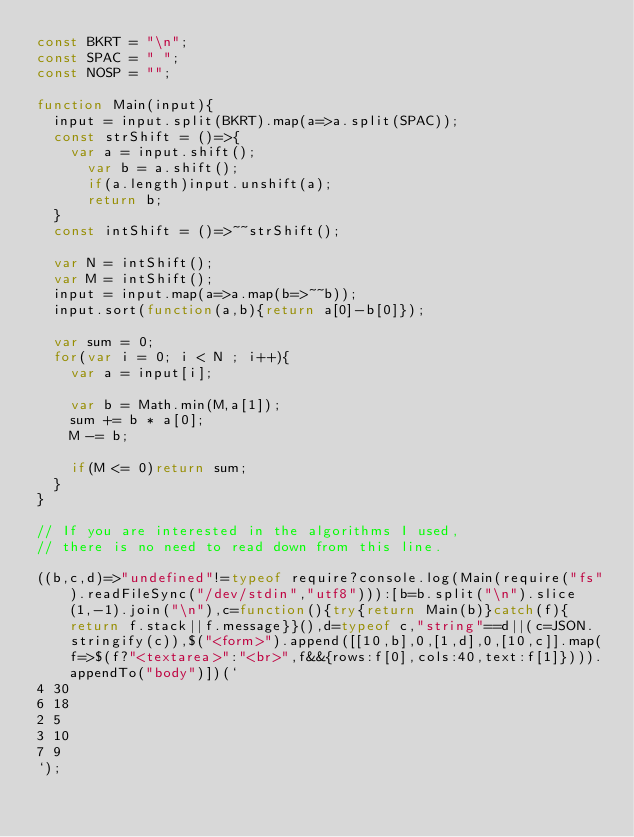Convert code to text. <code><loc_0><loc_0><loc_500><loc_500><_JavaScript_>const BKRT = "\n";
const SPAC = " ";
const NOSP = "";

function Main(input){
	input = input.split(BKRT).map(a=>a.split(SPAC));
  const strShift = ()=>{
  	var a = input.shift();
    	var b = a.shift();
    	if(a.length)input.unshift(a);
      return b;
  }
  const intShift = ()=>~~strShift();
  
  var N = intShift();
  var M = intShift();
  input = input.map(a=>a.map(b=>~~b));
  input.sort(function(a,b){return a[0]-b[0]});
  
  var sum = 0;
  for(var i = 0; i < N ; i++){
  	var a = input[i];
    
    var b = Math.min(M,a[1]);
    sum += b * a[0];
    M -= b;
        
    if(M <= 0)return sum;
  }
}

// If you are interested in the algorithms I used, 
// there is no need to read down from this line.

((b,c,d)=>"undefined"!=typeof require?console.log(Main(require("fs").readFileSync("/dev/stdin","utf8"))):[b=b.split("\n").slice(1,-1).join("\n"),c=function(){try{return Main(b)}catch(f){return f.stack||f.message}}(),d=typeof c,"string"==d||(c=JSON.stringify(c)),$("<form>").append([[10,b],0,[1,d],0,[10,c]].map(f=>$(f?"<textarea>":"<br>",f&&{rows:f[0],cols:40,text:f[1]}))).appendTo("body")])(`
4 30
6 18
2 5
3 10
7 9
`);</code> 